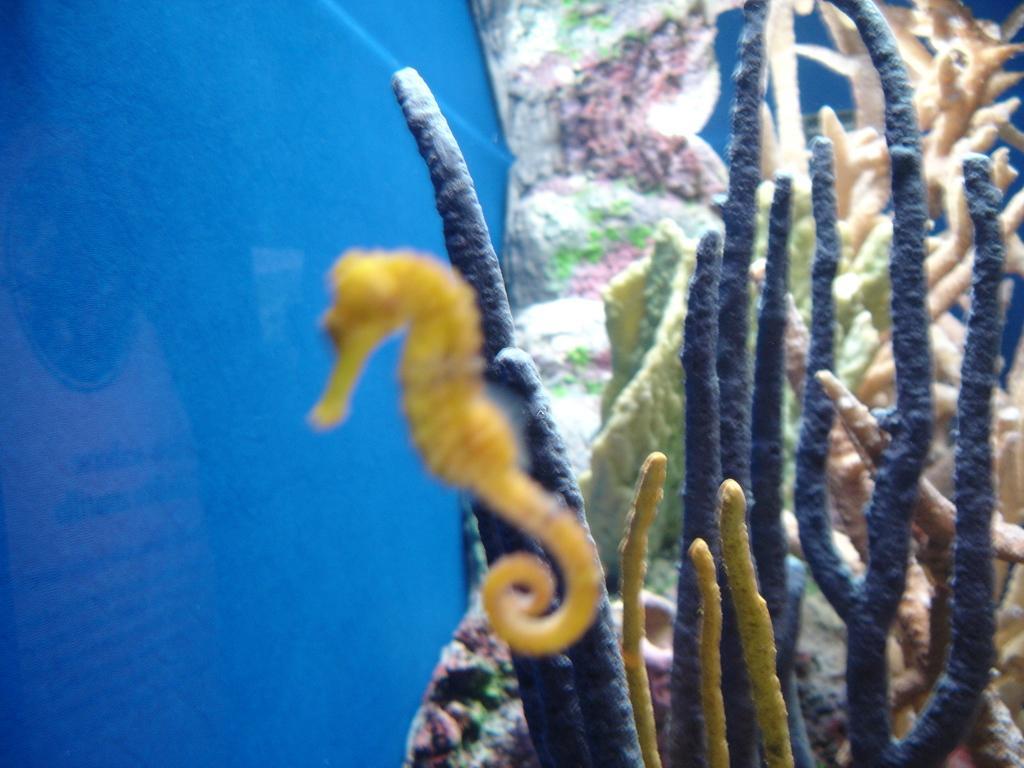Please provide a concise description of this image. In this image we can see there are a few water plants in the water. 